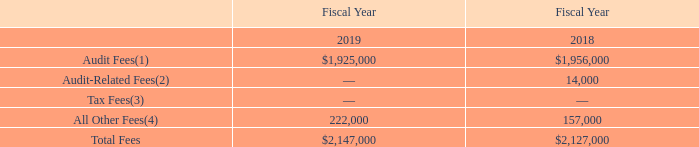Item 14. Principal Accountant Fees and Services
Fees For Professional Audit Services
The following is a summary of fees billed by the Company’s independent registered public accountants, PricewaterhouseCoopers LLP, for the years ended December 31, 2019 and 2018:
(1) Represents the aggregate fees billed for the audit of the Company’s financial statements, review of the financial statements included in the Company’s quarterly reports and services in connection with the statutory and regulatory filings or engagements for those years.
(2)  Represents the aggregate fees billed for assurance and related services that are reasonably related to the performance of the audit or review of the Company’s financial statements and are not reported under “audit fees.”
(3)  Represents the aggregate fees billed for tax compliance, advice and planning.
(4)  Represents the aggregate fees billed for all products and services provided that are not included under “audit fees,” “audit-related fees” or “tax fees.”
What is the name of Xperi Corporation’s independent registered public accountants called? Pricewaterhousecoopers llp. What does the table show us? A summary of fees billed by the company’s independent registered public accountants, pricewaterhousecoopers llp, for the years ended december 31, 2019 and 2018. What are the audit fees for the fiscal year 2018 and 2019, respectively? $1,956,000, $1,925,000. What is the proportion of audit fees and audit-related fees over total fees in the fiscal year 2018? (1,956,000+14,000)/2,127,000 
Answer: 0.93. What is the percentage change of audit fees from 2018 to 2019?
Answer scale should be: percent. (1,925,000-1,956,000)/1,956,000 
Answer: -1.58. What is the ratio of total fees in 2019 to total fees in 2018? 2,147,000/2,127,000 
Answer: 1.01. 